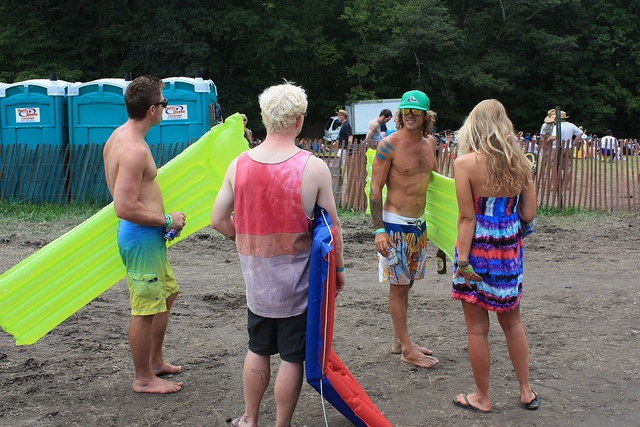Describe the objects in this image and their specific colors. I can see people in black, darkgray, brown, and gray tones, people in black, brown, gray, and maroon tones, people in black, gray, tan, and lightpink tones, surfboard in black, lightgreen, and lime tones, and people in black, brown, gray, and maroon tones in this image. 